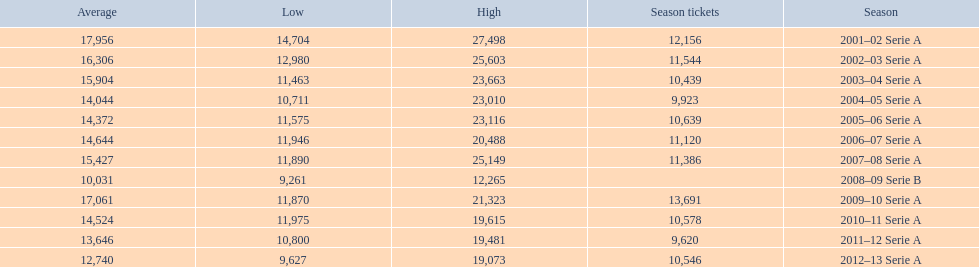What was the average attendance in 2008? 10,031. 